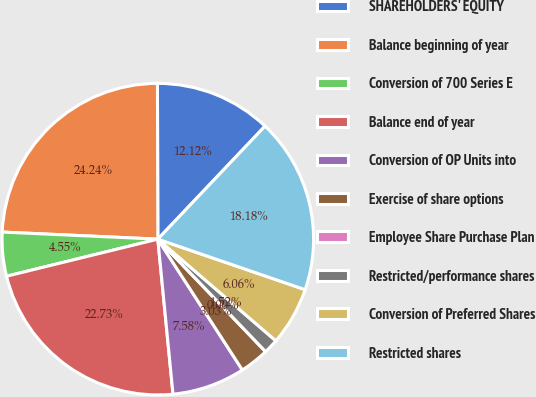Convert chart. <chart><loc_0><loc_0><loc_500><loc_500><pie_chart><fcel>SHAREHOLDERS' EQUITY<fcel>Balance beginning of year<fcel>Conversion of 700 Series E<fcel>Balance end of year<fcel>Conversion of OP Units into<fcel>Exercise of share options<fcel>Employee Share Purchase Plan<fcel>Restricted/performance shares<fcel>Conversion of Preferred Shares<fcel>Restricted shares<nl><fcel>12.12%<fcel>24.24%<fcel>4.55%<fcel>22.73%<fcel>7.58%<fcel>3.03%<fcel>0.0%<fcel>1.52%<fcel>6.06%<fcel>18.18%<nl></chart> 